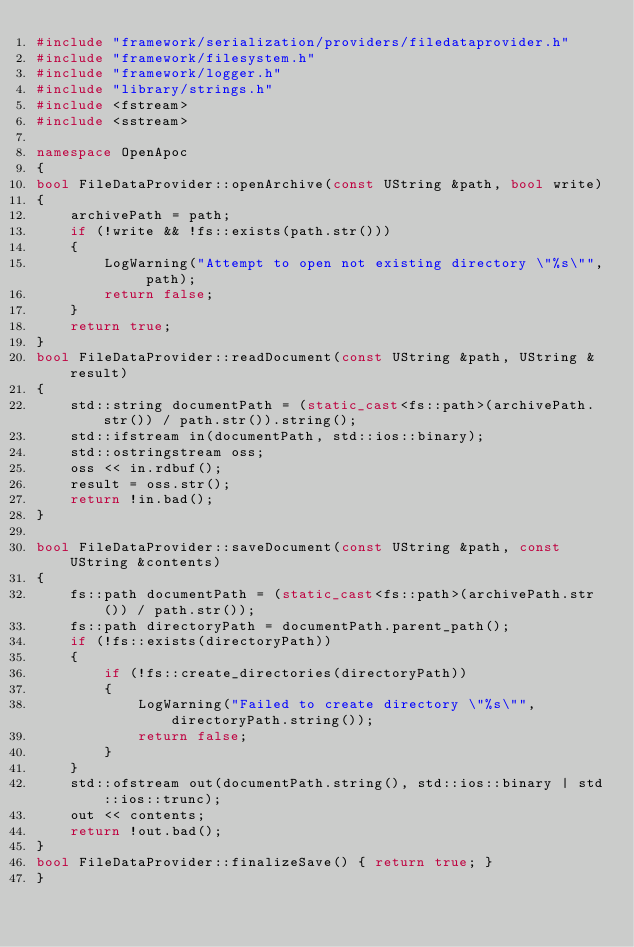Convert code to text. <code><loc_0><loc_0><loc_500><loc_500><_C++_>#include "framework/serialization/providers/filedataprovider.h"
#include "framework/filesystem.h"
#include "framework/logger.h"
#include "library/strings.h"
#include <fstream>
#include <sstream>

namespace OpenApoc
{
bool FileDataProvider::openArchive(const UString &path, bool write)
{
	archivePath = path;
	if (!write && !fs::exists(path.str()))
	{
		LogWarning("Attempt to open not existing directory \"%s\"", path);
		return false;
	}
	return true;
}
bool FileDataProvider::readDocument(const UString &path, UString &result)
{
	std::string documentPath = (static_cast<fs::path>(archivePath.str()) / path.str()).string();
	std::ifstream in(documentPath, std::ios::binary);
	std::ostringstream oss;
	oss << in.rdbuf();
	result = oss.str();
	return !in.bad();
}

bool FileDataProvider::saveDocument(const UString &path, const UString &contents)
{
	fs::path documentPath = (static_cast<fs::path>(archivePath.str()) / path.str());
	fs::path directoryPath = documentPath.parent_path();
	if (!fs::exists(directoryPath))
	{
		if (!fs::create_directories(directoryPath))
		{
			LogWarning("Failed to create directory \"%s\"", directoryPath.string());
			return false;
		}
	}
	std::ofstream out(documentPath.string(), std::ios::binary | std::ios::trunc);
	out << contents;
	return !out.bad();
}
bool FileDataProvider::finalizeSave() { return true; }
}
</code> 